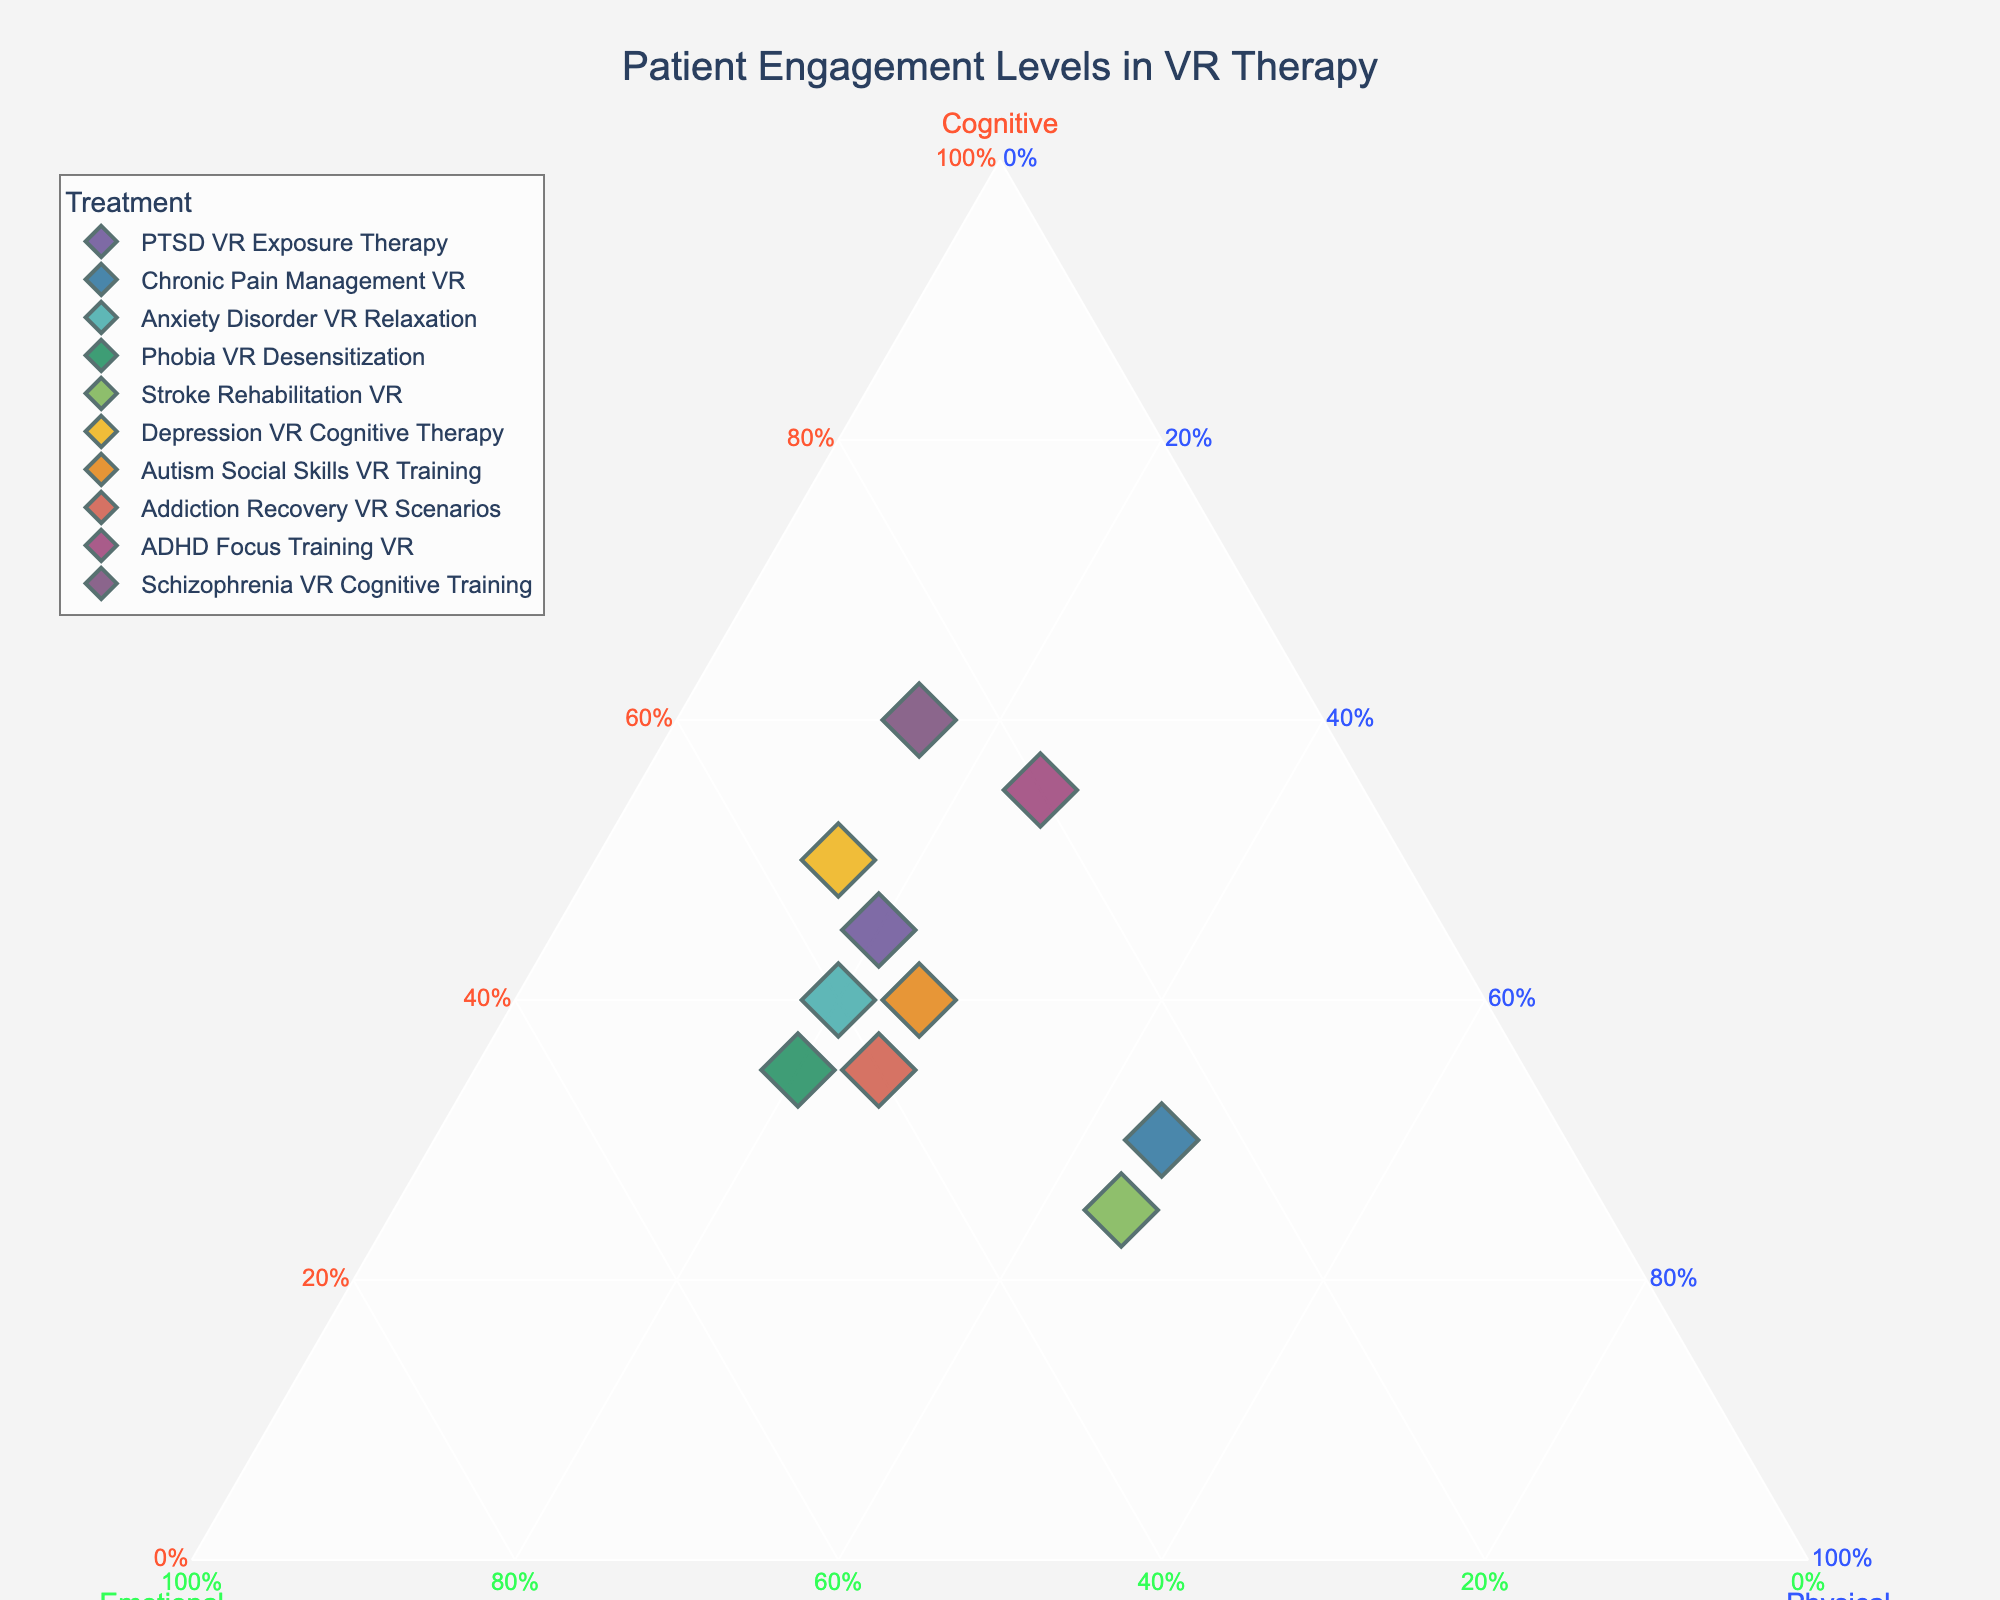What is the title of the plot? The title of the plot is typically displayed at the top center of the plot. It provides an overview of what the plot represents. In this case, the title clearly states the subject of the plot.
Answer: "Patient Engagement Levels in VR Therapy" Which treatment has the highest cognitive involvement? By looking at the vertex labeled "Cognitive," we can see which point is closest to it. The treatment represented by this point will have the highest cognitive involvement.
Answer: "Schizophrenia VR Cognitive Training" What are the patient engagement levels for ADHD Focus Training VR? Locate the point on the plot for "ADHD Focus Training VR" and hover over it to see the exact values for cognitive, emotional, and physical involvement.
Answer: Cognitive: 0.55, Emotional: 0.20, Physical: 0.25 Which treatments have equal physical involvement? Look at the points on the "Physical" vertex to identify treatments that are equidistant from this vertex. This indicates that they have equal levels of physical involvement.
Answer: "Chronic Pain Management VR" and "Stroke Rehabilitation VR" both have 0.45 physical involvement Among the treatments, which one has the least emotional involvement? Find the point furthest from the "Emotional" vertex. The treatment represented by this point will have the lowest emotional involvement.
Answer: "ADHD Focus Training VR" How do the cognitive engagement levels of PTSD VR Exposure Therapy and Depression VR Cognitive Therapy compare? Locate these two points on the ternary plot and compare their positions relative to the "Cognitive" vertex to determine which has higher cognitive involvement.
Answer: Depression VR Cognitive Therapy has higher cognitive involvement (0.50 vs. 0.45) What is the average cognitive involvement across all treatments? Sum up the cognitive involvement values for all treatments and divide by the number of treatments to get the average.
Answer: (0.45 + 0.30 + 0.40 + 0.35 + 0.25 + 0.50 + 0.40 + 0.35 + 0.55 + 0.60) / 10 = 0.415 Which treatments have a higher emotional involvement than PTSD VR Exposure Therapy but lower physical involvement compared to Chronic Pain Management VR? Compare the emotional and physical values across treatments. The emotional involvement of PTSD VR Exposure Therapy is 0.35, and the physical involvement for Chronic Pain Management VR is 0.45. Identify the treatments fitting these criteria.
Answer: "Anxiety Disorder VR Relaxation" and "Addiction Recovery VR Scenarios" Which treatment has the closest balance among cognitive, emotional, and physical involvement? Look for the point that lies closest to the center of the triangle, indicating a more balanced engagement across all three dimensions.
Answer: "Autism Social Skills VR Training" 